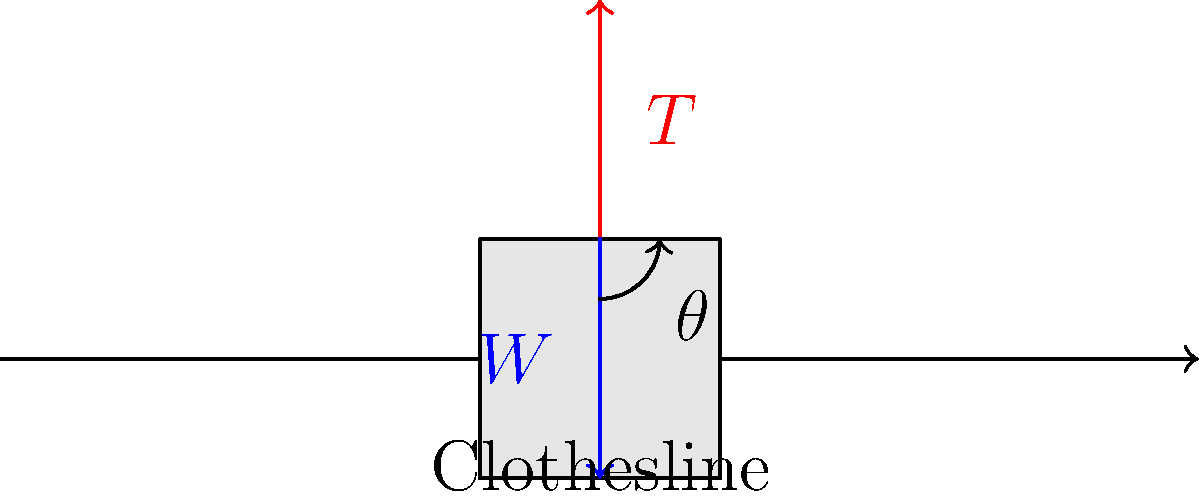When hanging laundry outside, you notice that your shirt forms an angle $\theta$ with the vertical. If the weight of the shirt is $W$ and the tension in the clothesline at the point where the shirt is attached is $T$, what is the relationship between $W$, $T$, and $\theta$? Let's approach this step-by-step:

1. The shirt is in equilibrium, so the sum of all forces acting on it must be zero.

2. There are two forces acting on the shirt:
   - The weight ($W$) acting downward
   - The tension in the clothesline ($T$) acting at an angle $\theta$ from the vertical

3. We can break down the tension force into vertical and horizontal components:
   - Vertical component: $T \cos\theta$
   - Horizontal component: $T \sin\theta$

4. For equilibrium in the vertical direction:
   $T \cos\theta = W$

5. This equation represents the relationship between $W$, $T$, and $\theta$.

6. We can rearrange this to express $T$ in terms of $W$ and $\theta$:
   $T = \frac{W}{\cos\theta}$

This final equation shows how the tension in the clothesline relates to the weight of the shirt and the angle it makes with the vertical.
Answer: $T = \frac{W}{\cos\theta}$ 